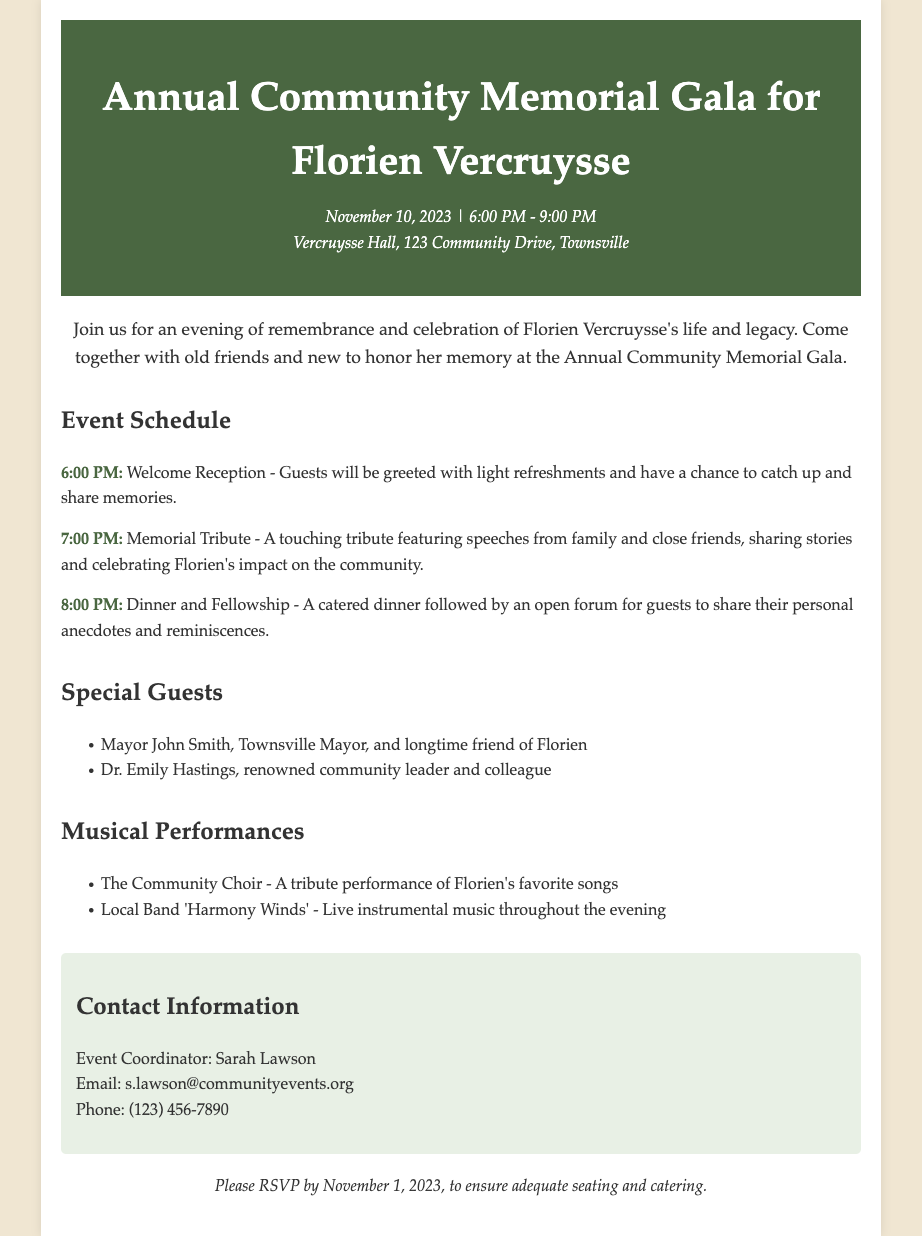What date is the memorial gala? The date is provided in the document as the specific day for the event, which is November 10, 2023.
Answer: November 10, 2023 What is the time duration of the gala? The document specifies the starting and ending time of the event as 6:00 PM to 9:00 PM.
Answer: 6:00 PM - 9:00 PM Where is the venue of the gala? The document lists Vercruysse Hall, located at 123 Community Drive, Townsville, as the venue for the event.
Answer: Vercruysse Hall, 123 Community Drive, Townsville Who will speak at the Memorial Tribute? The document mentions that the tribute will feature speeches from family and close friends sharing stories about Florien.
Answer: Family and close friends What is the last date to RSVP? The document specifies that RSVPs must be sent in by November 1, 2023.
Answer: November 1, 2023 What type of performances will be featured during the gala? The document mentions a tribute performance by The Community Choir and live music by a local band throughout the evening.
Answer: Tribute performance and live music Who is the event coordinator? The document states that Sarah Lawson is the event coordinator responsible for organizing the gala.
Answer: Sarah Lawson How many main events are listed in the schedule? The document outlines three main events as part of the gala's schedule: Welcome Reception, Memorial Tribute, and Dinner and Fellowship.
Answer: Three Who is one of the special guests? The document lists Mayor John Smith as one of the notable attendees at the event honoring Florien's memory.
Answer: Mayor John Smith 